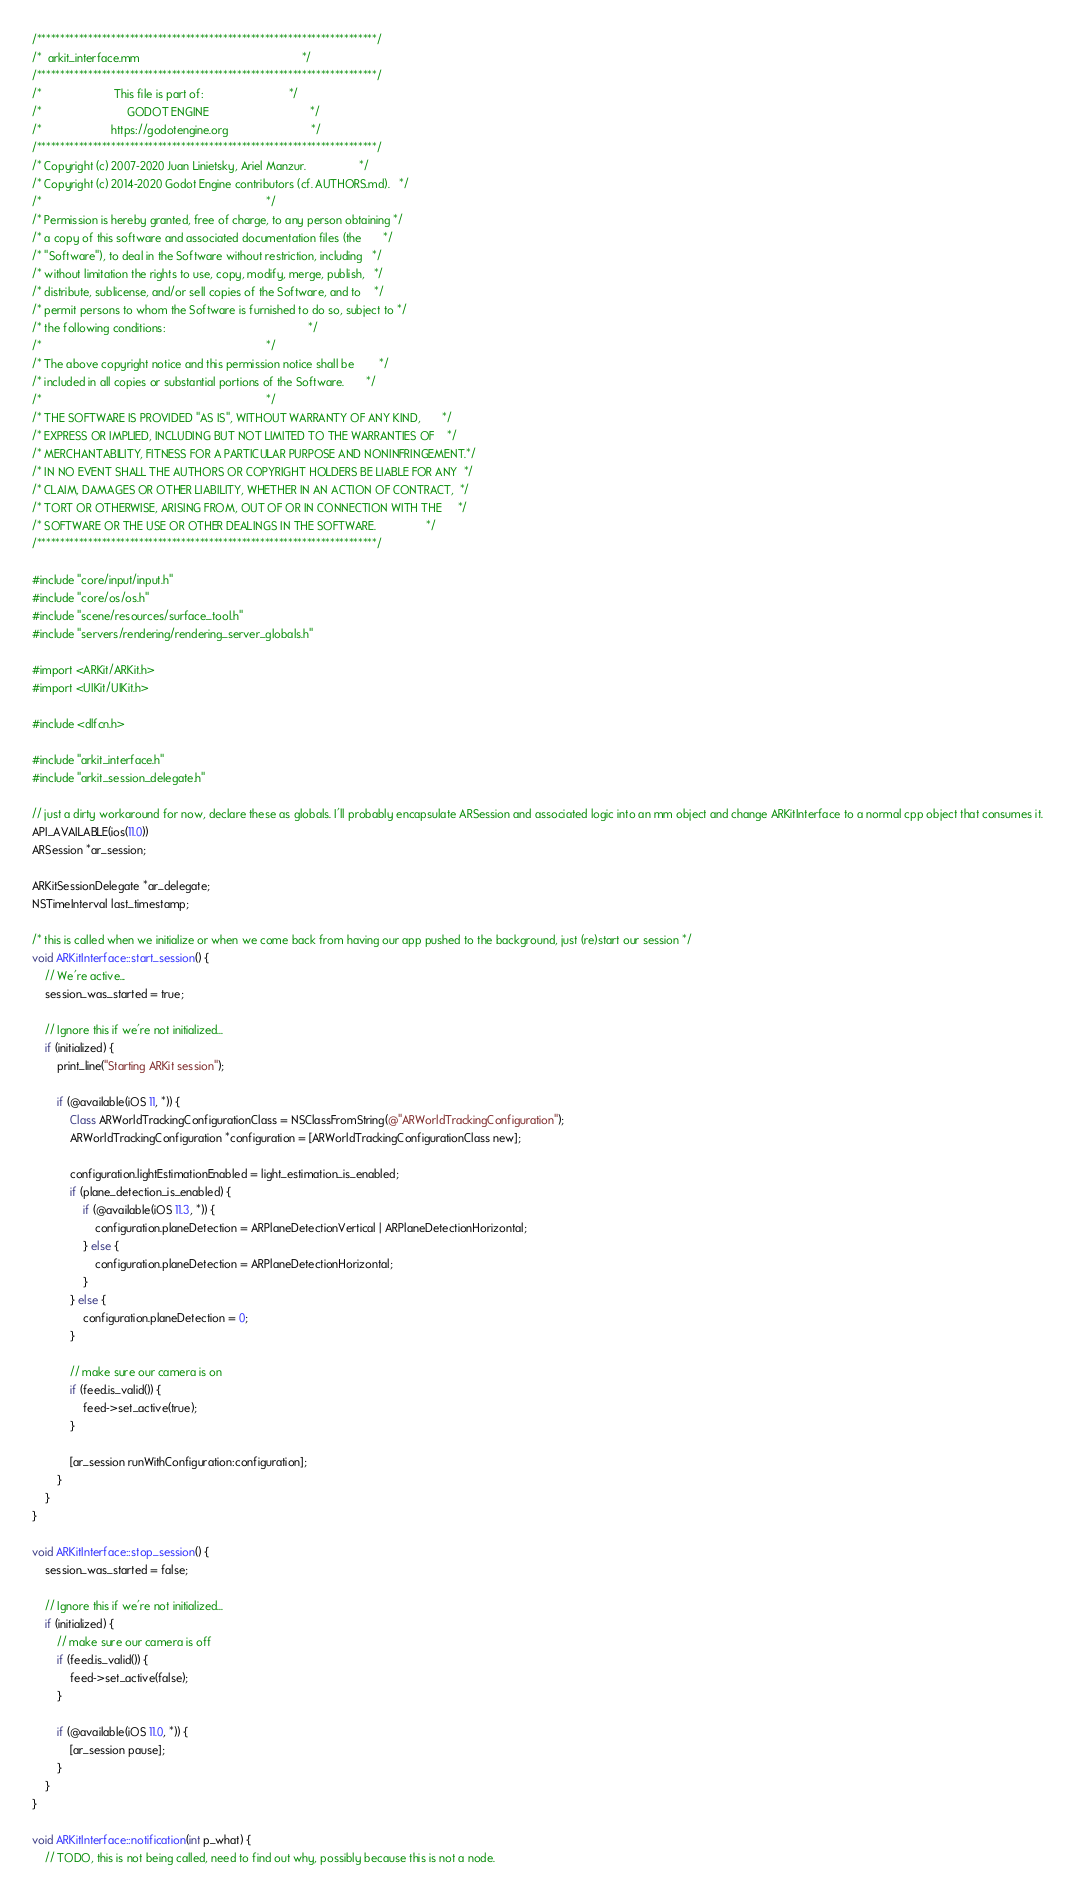<code> <loc_0><loc_0><loc_500><loc_500><_ObjectiveC_>/*************************************************************************/
/*  arkit_interface.mm                                                   */
/*************************************************************************/
/*                       This file is part of:                           */
/*                           GODOT ENGINE                                */
/*                      https://godotengine.org                          */
/*************************************************************************/
/* Copyright (c) 2007-2020 Juan Linietsky, Ariel Manzur.                 */
/* Copyright (c) 2014-2020 Godot Engine contributors (cf. AUTHORS.md).   */
/*                                                                       */
/* Permission is hereby granted, free of charge, to any person obtaining */
/* a copy of this software and associated documentation files (the       */
/* "Software"), to deal in the Software without restriction, including   */
/* without limitation the rights to use, copy, modify, merge, publish,   */
/* distribute, sublicense, and/or sell copies of the Software, and to    */
/* permit persons to whom the Software is furnished to do so, subject to */
/* the following conditions:                                             */
/*                                                                       */
/* The above copyright notice and this permission notice shall be        */
/* included in all copies or substantial portions of the Software.       */
/*                                                                       */
/* THE SOFTWARE IS PROVIDED "AS IS", WITHOUT WARRANTY OF ANY KIND,       */
/* EXPRESS OR IMPLIED, INCLUDING BUT NOT LIMITED TO THE WARRANTIES OF    */
/* MERCHANTABILITY, FITNESS FOR A PARTICULAR PURPOSE AND NONINFRINGEMENT.*/
/* IN NO EVENT SHALL THE AUTHORS OR COPYRIGHT HOLDERS BE LIABLE FOR ANY  */
/* CLAIM, DAMAGES OR OTHER LIABILITY, WHETHER IN AN ACTION OF CONTRACT,  */
/* TORT OR OTHERWISE, ARISING FROM, OUT OF OR IN CONNECTION WITH THE     */
/* SOFTWARE OR THE USE OR OTHER DEALINGS IN THE SOFTWARE.                */
/*************************************************************************/

#include "core/input/input.h"
#include "core/os/os.h"
#include "scene/resources/surface_tool.h"
#include "servers/rendering/rendering_server_globals.h"

#import <ARKit/ARKit.h>
#import <UIKit/UIKit.h>

#include <dlfcn.h>

#include "arkit_interface.h"
#include "arkit_session_delegate.h"

// just a dirty workaround for now, declare these as globals. I'll probably encapsulate ARSession and associated logic into an mm object and change ARKitInterface to a normal cpp object that consumes it.
API_AVAILABLE(ios(11.0))
ARSession *ar_session;

ARKitSessionDelegate *ar_delegate;
NSTimeInterval last_timestamp;

/* this is called when we initialize or when we come back from having our app pushed to the background, just (re)start our session */
void ARKitInterface::start_session() {
	// We're active...
	session_was_started = true;

	// Ignore this if we're not initialized...
	if (initialized) {
		print_line("Starting ARKit session");

		if (@available(iOS 11, *)) {
			Class ARWorldTrackingConfigurationClass = NSClassFromString(@"ARWorldTrackingConfiguration");
			ARWorldTrackingConfiguration *configuration = [ARWorldTrackingConfigurationClass new];

			configuration.lightEstimationEnabled = light_estimation_is_enabled;
			if (plane_detection_is_enabled) {
				if (@available(iOS 11.3, *)) {
					configuration.planeDetection = ARPlaneDetectionVertical | ARPlaneDetectionHorizontal;
				} else {
					configuration.planeDetection = ARPlaneDetectionHorizontal;
				}
			} else {
				configuration.planeDetection = 0;
			}

			// make sure our camera is on
			if (feed.is_valid()) {
				feed->set_active(true);
			}

			[ar_session runWithConfiguration:configuration];
		}
	}
}

void ARKitInterface::stop_session() {
	session_was_started = false;

	// Ignore this if we're not initialized...
	if (initialized) {
		// make sure our camera is off
		if (feed.is_valid()) {
			feed->set_active(false);
		}

		if (@available(iOS 11.0, *)) {
			[ar_session pause];
		}
	}
}

void ARKitInterface::notification(int p_what) {
	// TODO, this is not being called, need to find out why, possibly because this is not a node.</code> 